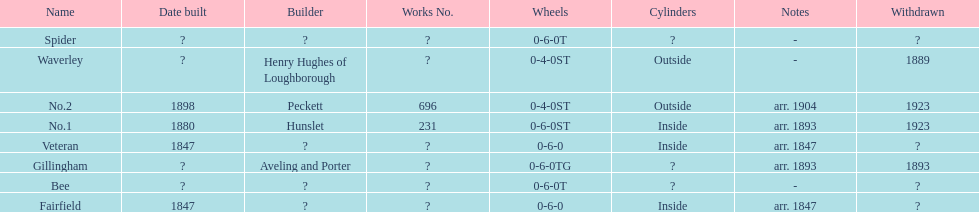How long after fairfield was no. 1 built? 33 years. 